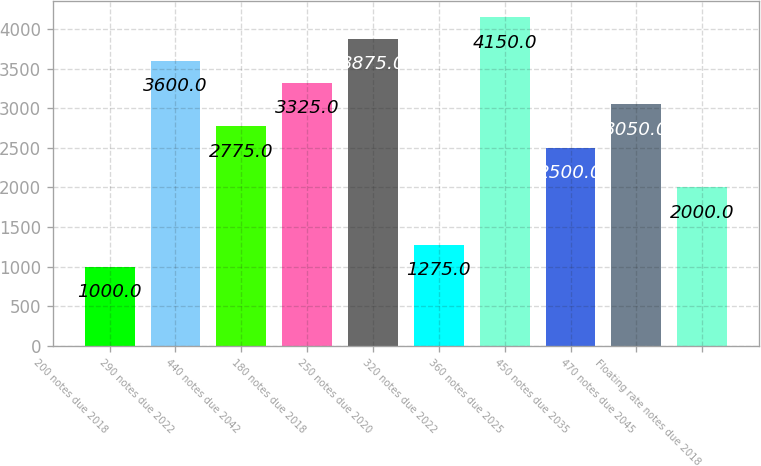Convert chart to OTSL. <chart><loc_0><loc_0><loc_500><loc_500><bar_chart><fcel>200 notes due 2018<fcel>290 notes due 2022<fcel>440 notes due 2042<fcel>180 notes due 2018<fcel>250 notes due 2020<fcel>320 notes due 2022<fcel>360 notes due 2025<fcel>450 notes due 2035<fcel>470 notes due 2045<fcel>Floating rate notes due 2018<nl><fcel>1000<fcel>3600<fcel>2775<fcel>3325<fcel>3875<fcel>1275<fcel>4150<fcel>2500<fcel>3050<fcel>2000<nl></chart> 